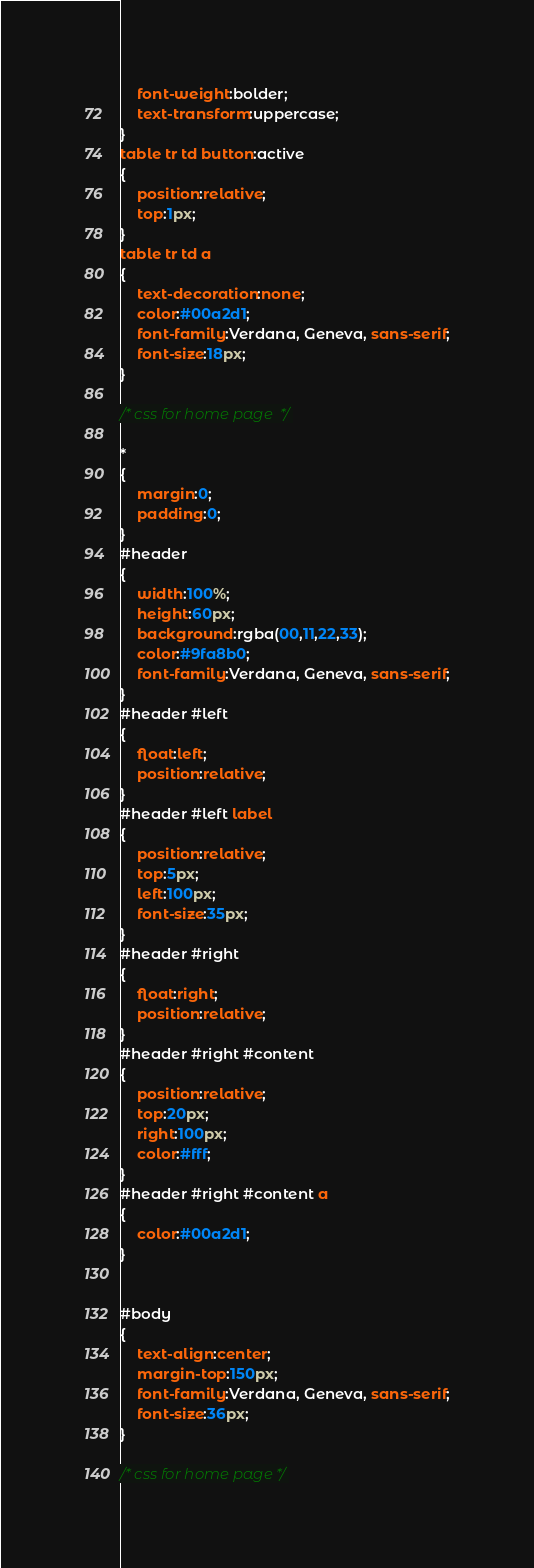Convert code to text. <code><loc_0><loc_0><loc_500><loc_500><_CSS_>	font-weight:bolder;
	text-transform:uppercase;
}
table tr td button:active
{
	position:relative;
	top:1px;
}
table tr td a
{
	text-decoration:none;
	color:#00a2d1;
	font-family:Verdana, Geneva, sans-serif;
	font-size:18px;
}

/* css for home page  */

*
{
	margin:0;
	padding:0;
}
#header
{
	width:100%;
	height:60px;
	background:rgba(00,11,22,33);
	color:#9fa8b0;
	font-family:Verdana, Geneva, sans-serif;
}
#header #left
{
	float:left;
	position:relative;
}
#header #left label
{
	position:relative;
	top:5px;
	left:100px;
	font-size:35px;
}
#header #right
{
	float:right;
	position:relative;
}
#header #right #content
{
	position:relative;
	top:20px;
	right:100px;
	color:#fff;
}
#header #right #content a
{
	color:#00a2d1;
}


#body
{
	text-align:center;
	margin-top:150px;
	font-family:Verdana, Geneva, sans-serif;
	font-size:36px;
}

/* css for home page */
</code> 